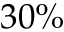<formula> <loc_0><loc_0><loc_500><loc_500>3 0 \%</formula> 